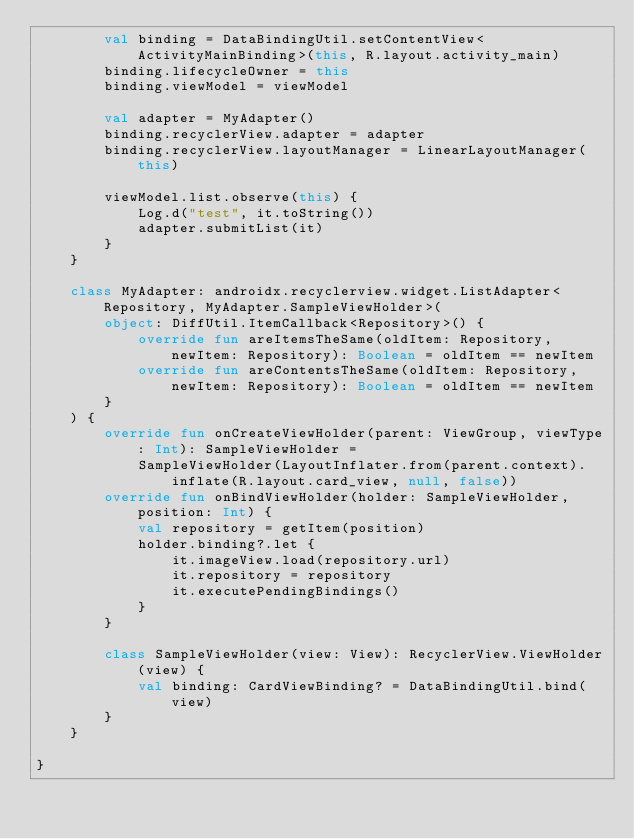Convert code to text. <code><loc_0><loc_0><loc_500><loc_500><_Kotlin_>        val binding = DataBindingUtil.setContentView<ActivityMainBinding>(this, R.layout.activity_main)
        binding.lifecycleOwner = this
        binding.viewModel = viewModel

        val adapter = MyAdapter()
        binding.recyclerView.adapter = adapter
        binding.recyclerView.layoutManager = LinearLayoutManager(this)

        viewModel.list.observe(this) {
            Log.d("test", it.toString())
            adapter.submitList(it)
        }
    }

    class MyAdapter: androidx.recyclerview.widget.ListAdapter<Repository, MyAdapter.SampleViewHolder>(
        object: DiffUtil.ItemCallback<Repository>() {
            override fun areItemsTheSame(oldItem: Repository, newItem: Repository): Boolean = oldItem == newItem
            override fun areContentsTheSame(oldItem: Repository, newItem: Repository): Boolean = oldItem == newItem
        }
    ) {
        override fun onCreateViewHolder(parent: ViewGroup, viewType: Int): SampleViewHolder =
            SampleViewHolder(LayoutInflater.from(parent.context).inflate(R.layout.card_view, null, false))
        override fun onBindViewHolder(holder: SampleViewHolder, position: Int) {
            val repository = getItem(position)
            holder.binding?.let {
                it.imageView.load(repository.url)
                it.repository = repository
                it.executePendingBindings()
            }
        }

        class SampleViewHolder(view: View): RecyclerView.ViewHolder(view) {
            val binding: CardViewBinding? = DataBindingUtil.bind(view)
        }
    }

}
</code> 